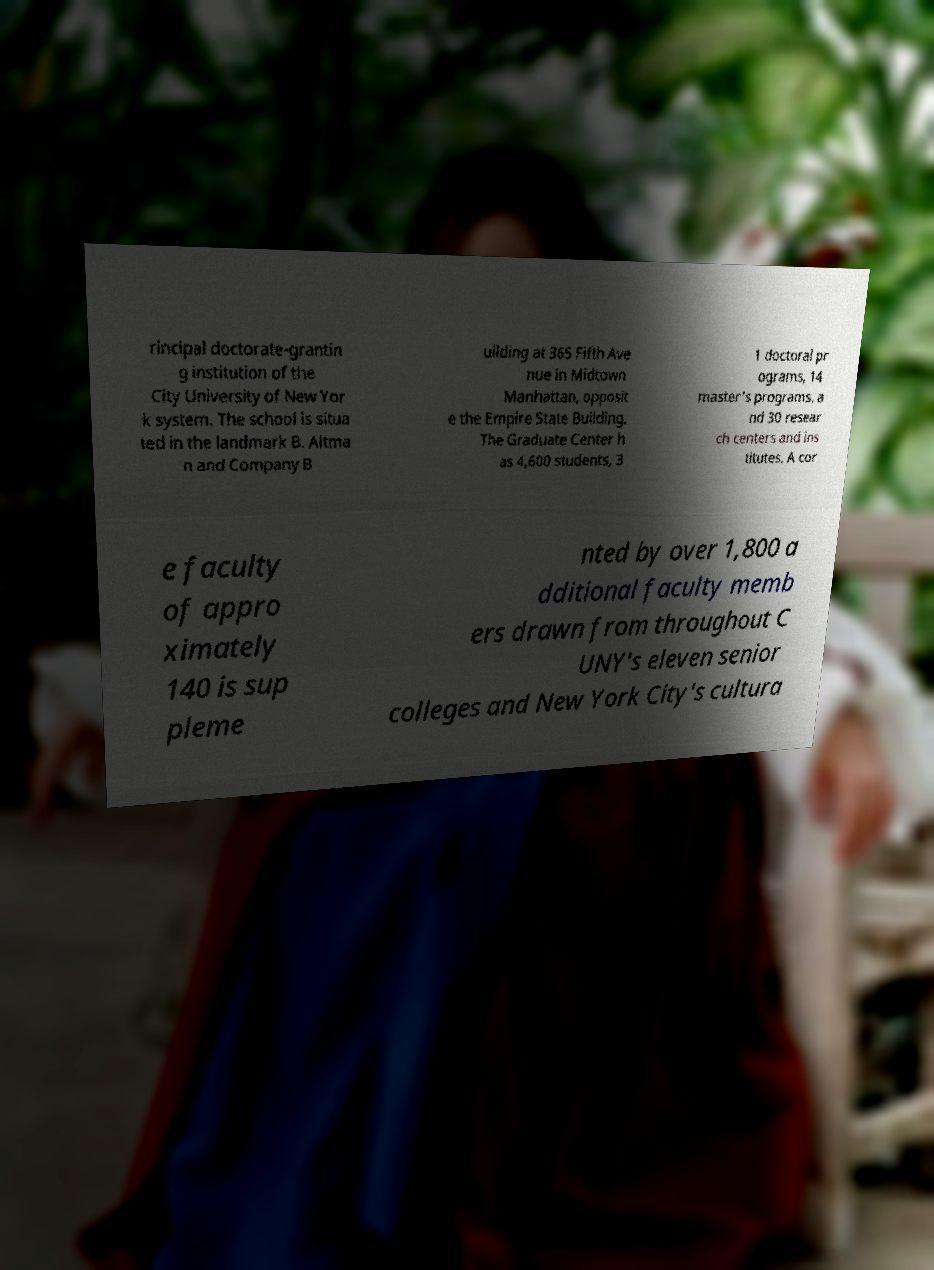There's text embedded in this image that I need extracted. Can you transcribe it verbatim? rincipal doctorate-grantin g institution of the City University of New Yor k system. The school is situa ted in the landmark B. Altma n and Company B uilding at 365 Fifth Ave nue in Midtown Manhattan, opposit e the Empire State Building. The Graduate Center h as 4,600 students, 3 1 doctoral pr ograms, 14 master's programs, a nd 30 resear ch centers and ins titutes. A cor e faculty of appro ximately 140 is sup pleme nted by over 1,800 a dditional faculty memb ers drawn from throughout C UNY's eleven senior colleges and New York City's cultura 